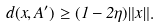<formula> <loc_0><loc_0><loc_500><loc_500>d ( x , A ^ { \prime } ) \geq ( 1 - 2 \eta ) \| x \| .</formula> 